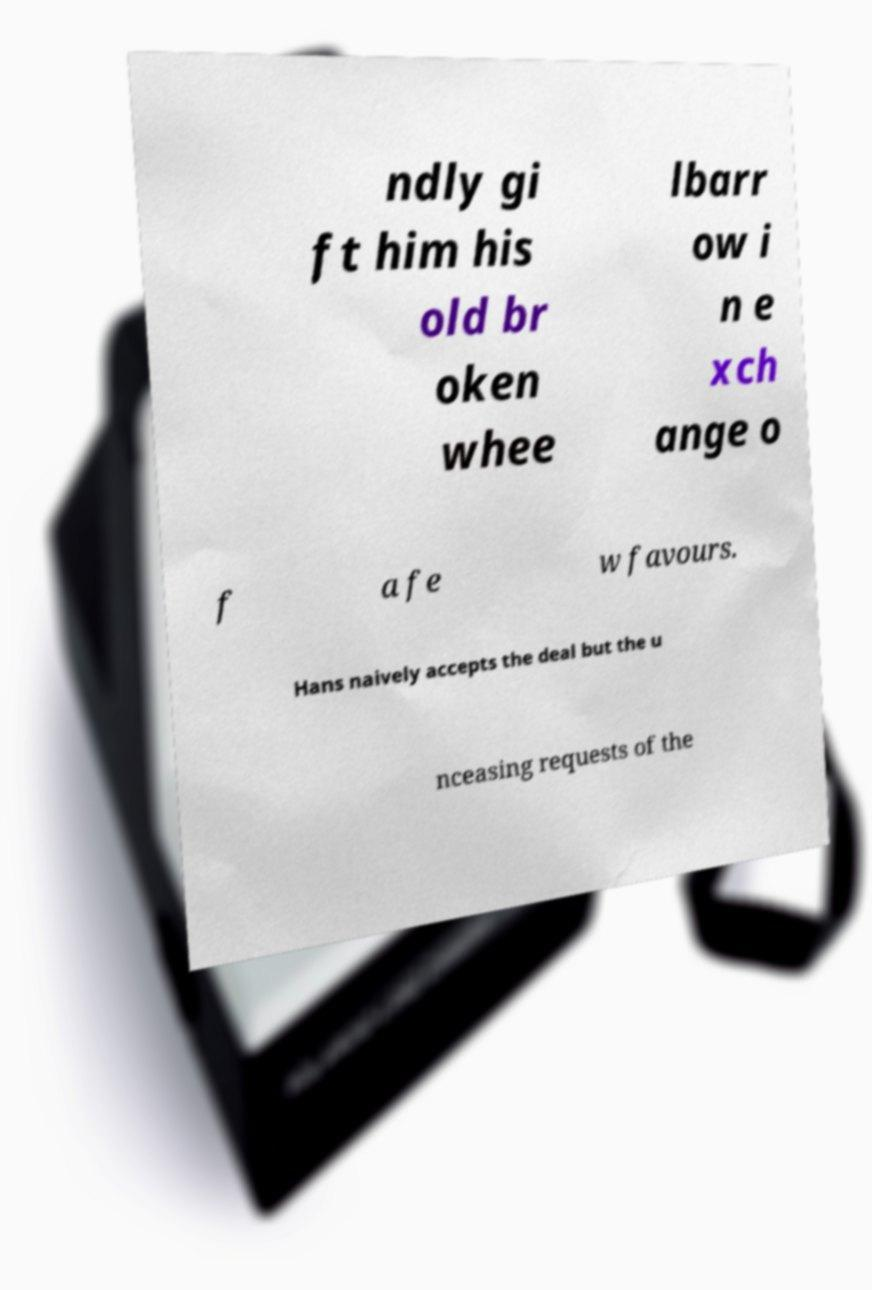For documentation purposes, I need the text within this image transcribed. Could you provide that? ndly gi ft him his old br oken whee lbarr ow i n e xch ange o f a fe w favours. Hans naively accepts the deal but the u nceasing requests of the 